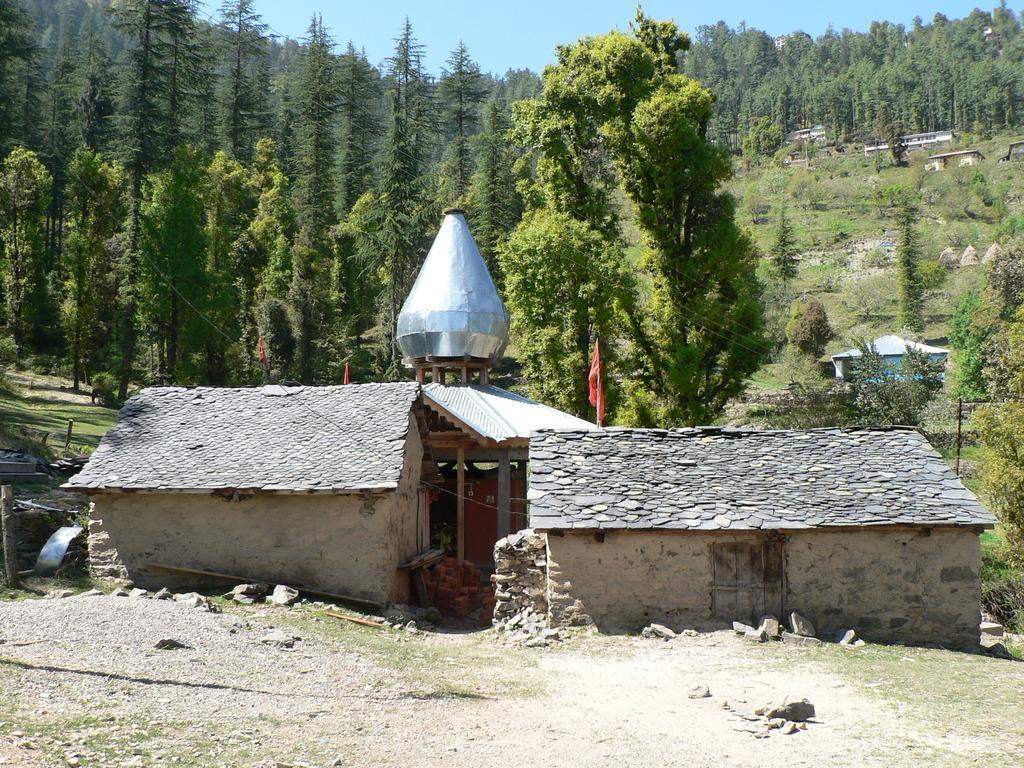Could you give a brief overview of what you see in this image? This image consists of trees in the middle. There is sky at the top. There is something like house in the middle. 